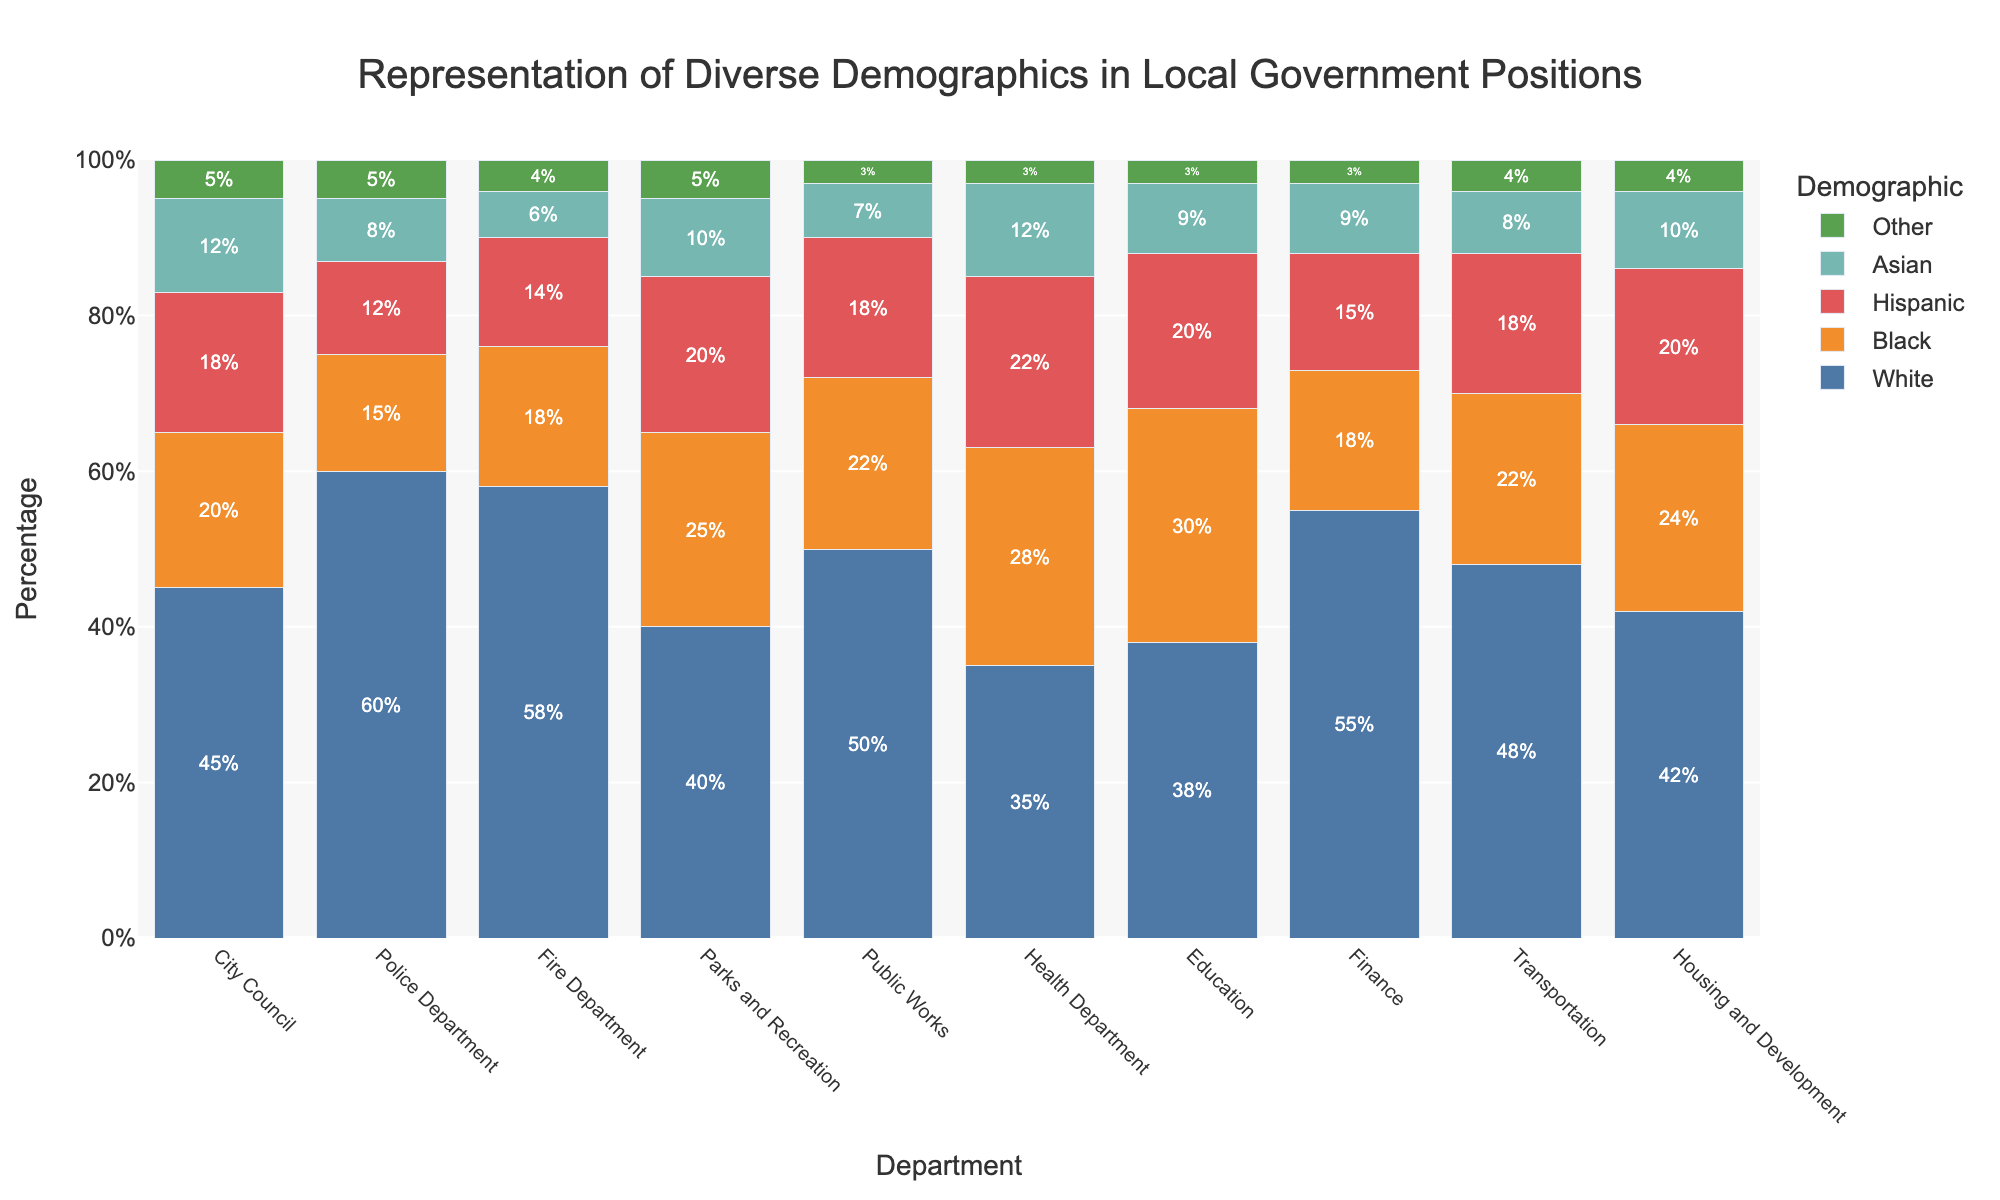Which department has the highest percentage of Black representation? Look at the bar chart and identify the department with the tallest bar segment representing Black individuals. The Health Department and Education both have the highest Black representation at 30%.
Answer: Health Department, Education Which demographic group is most represented in the Parks and Recreation department? Check the bar segments for Parks and Recreation and note which demographic has the largest portion. It is the Black demographic at 25%.
Answer: Black How does the percentage of Hispanic representation in the City Council compare to the Police Department? Examine the bars for Hispanic representation in both the City Council and Police Department. City Council has 18% Hispanic, whereas the Police Department has 12%.
Answer: City Council has a higher percentage What is the total percentage representation of minorities (Black, Hispanic, Asian, Other) in the Fire Department? Sum up the percentages of Black, Hispanic, Asian, and Other demographics in the Fire Department (18% + 14% + 6% + 4%).
Answer: 42% Which department has the highest overall diversity (i.e., the sum of all minority groups)? Calculate the sum of Black, Hispanic, Asian, and Other percentages for each department and compare. The Health Department has the highest diversity (28% + 22% + 12% + 3% = 65%).
Answer: Health Department Compare the representation of the Asian demographic in the Education and Finance departments. Which is higher, and by how much? Look at the percentages of the Asian demographic in both departments. Education has 9% Asian, while Finance has 9% Asian, so they are equal.
Answer: They are equal What is the difference in the percentage of White representation between the City Council and the Transportation department? Subtract the White percentage in Transportation from the White percentage in City Council (45% - 48%).
Answer: -3% Which department has the closest percentage of Hispanic and Asian representations? Look for the departments where the differences between Hispanic and Asian percentages are minimal. In Health Department, Hispanic is 22% and Asian is 12%, making a difference of 10%, which is minimal compared to other differences.
Answer: Health Department What is the combined percentage of White and Other demographics in the Police Department? Add the percentages of White and Other demographics in the Police Department (60% + 5%).
Answer: 65% Which department has the smallest percentage of Asian representation, and what is that percentage? Find the shortest bar segment for Asian representation across all departments. This is 6% in the Fire Department.
Answer: Fire Department, 6% 